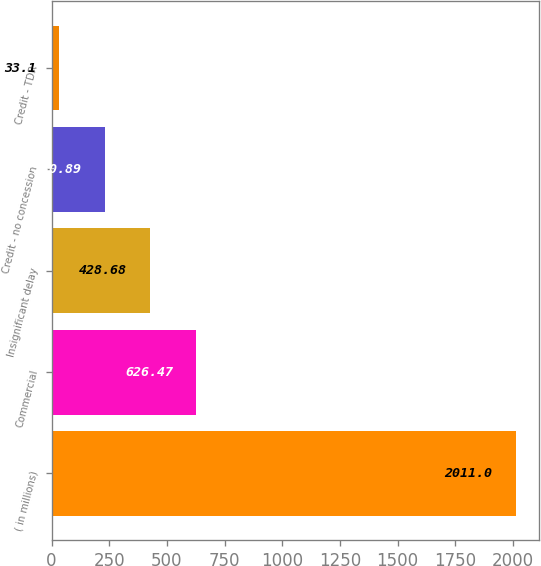Convert chart to OTSL. <chart><loc_0><loc_0><loc_500><loc_500><bar_chart><fcel>( in millions)<fcel>Commercial<fcel>Insignificant delay<fcel>Credit - no concession<fcel>Credit - TDR<nl><fcel>2011<fcel>626.47<fcel>428.68<fcel>230.89<fcel>33.1<nl></chart> 